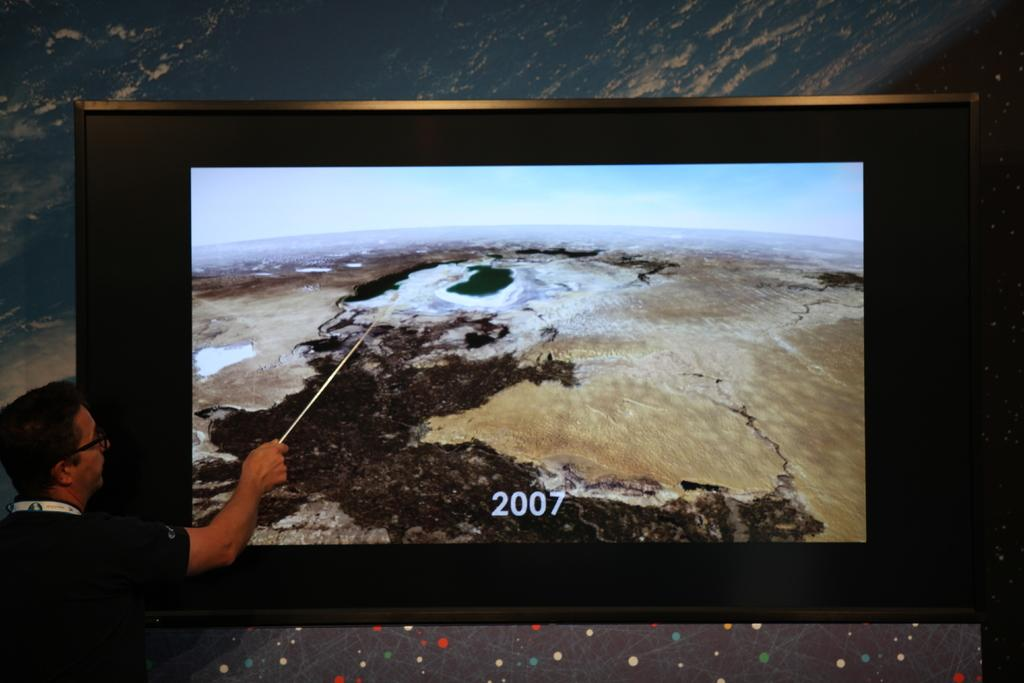<image>
Provide a brief description of the given image. A man pointing toward a scene on a picture with 2007 on it. 